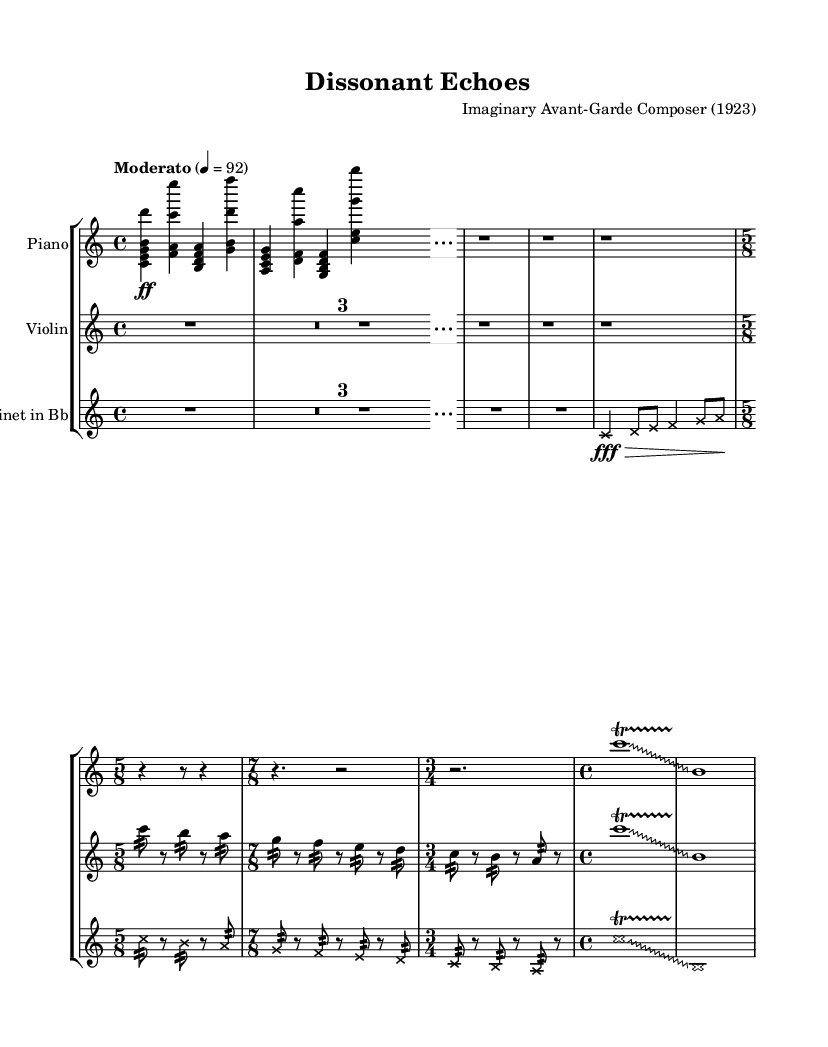What is the time signature of the piece? The time signature can be found in the symbol at the beginning of the score. It shows that the piece transitions between 4/4, 5/8, 7/8, and 3/4, indicating a changing rhythmic structure. The primary time signature initially presented is 4/4.
Answer: 4/4 What is the tempo marking given in the sheet music? The tempo marking is indicated above the staff; it states "Moderato" with a metronome marking of 92 beats per minute. This describes the speed of the performance.
Answer: Moderato 92 Which instruments are featured in the score? The instruments can be identified at the beginning of each staff labeled with their names. The score includes a Piano, Violin, and Clarinet in B flat.
Answer: Piano, Violin, Clarinet in B flat How many measures are there in Theme A? To determine the number of measures in Theme A, we can count each measure from the beginning when it first appears until it concludes. It appears to last for 8 measures.
Answer: 8 measures What is the musical texture during the introduction? By analyzing the introduction, we see that it features all three instruments playing distinct parts simultaneously, creating a rich harmonic texture characteristic of avant-garde music.
Answer: Polyphonic Describe the change in time signature during Theme B. In Theme B, we notice a shift from 4/4 to 5/8, followed by 7/8, and concluding with 3/4. This change in time signatures reflects experimentation with rhythm, typical of early 20th-century avant-garde compositions.
Answer: 5/8, 7/8, 3/4 What type of ornamentation is used at the end of the piece? The ornamentation at the end of the piece consists of a glissando followed by a trill, both enhancing expressiveness in performance. This technique is typical in avant-garde music to emphasize emotional depth.
Answer: Glissando, trill 